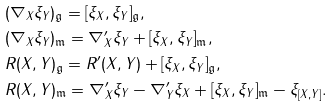<formula> <loc_0><loc_0><loc_500><loc_500>& ( \nabla _ { X } \xi _ { Y } ) _ { \mathfrak { g } } = [ \xi _ { X } , \xi _ { Y } ] _ { \mathfrak { g } } , \\ & ( \nabla _ { X } \xi _ { Y } ) _ { \mathfrak { m } } = \nabla ^ { \prime } _ { X } \xi _ { Y } + [ \xi _ { X } , \xi _ { Y } ] _ { \mathfrak { m } } , \\ & R ( X , Y ) _ { \mathfrak { g } } = R ^ { \prime } ( X , Y ) + [ \xi _ { X } , \xi _ { Y } ] _ { \mathfrak { g } } , \\ & R ( X , Y ) _ { \mathfrak { m } } = \nabla ^ { \prime } _ { X } \xi _ { Y } - \nabla ^ { \prime } _ { Y } \xi _ { X } + [ \xi _ { X } , \xi _ { Y } ] _ { \mathfrak { m } } - \xi _ { [ X , Y ] } .</formula> 